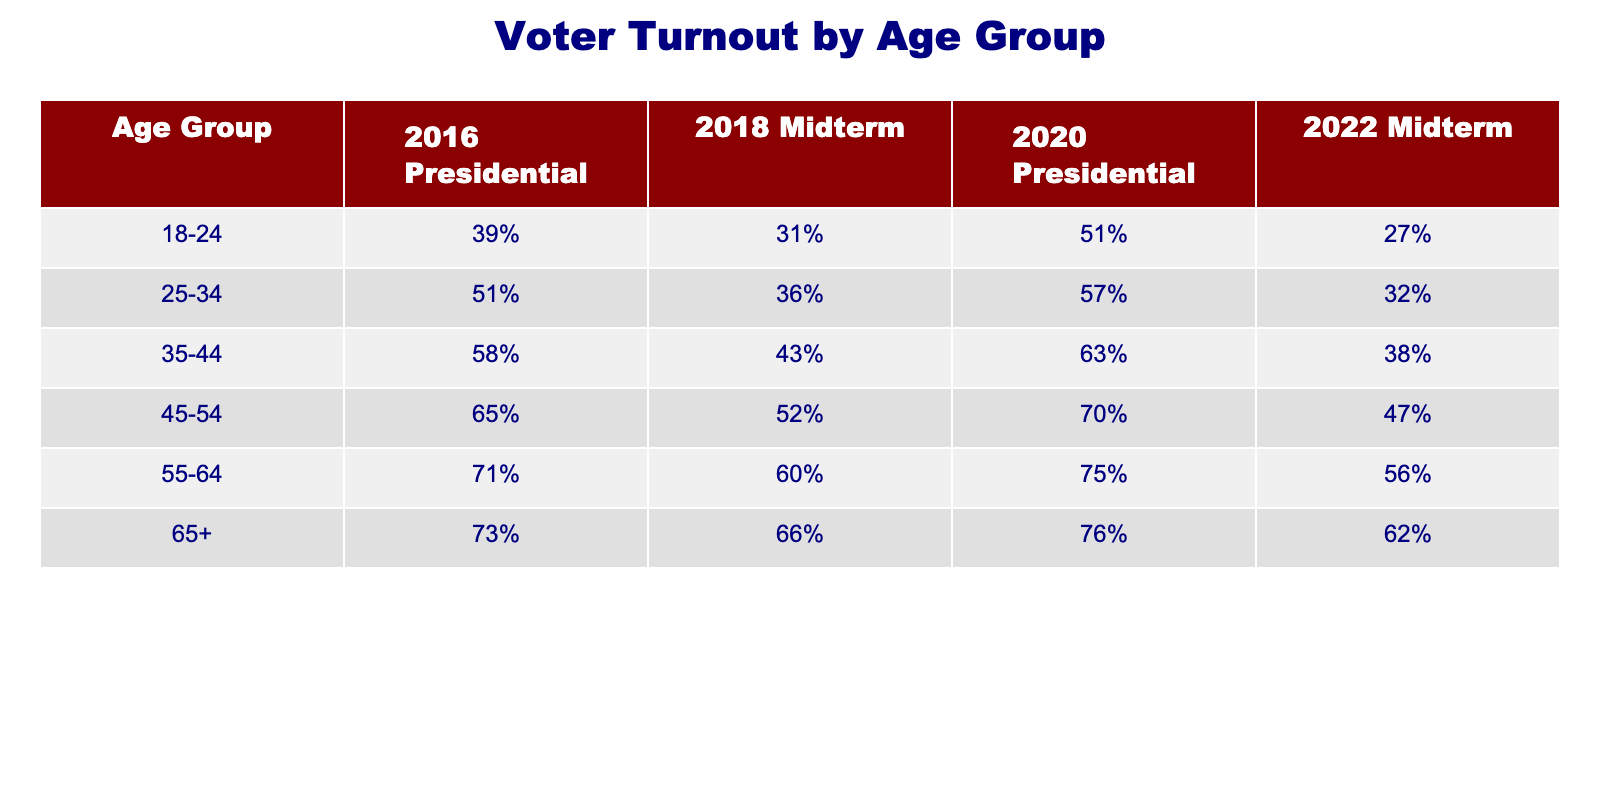What was the voter turnout for the 45-54 age group in the 2022 Midterm? In the table, we look for the row corresponding to the age group 45-54 and read the column for the 2022 Midterm, which shows 47%.
Answer: 47% Which age group had the highest voter turnout in the 2020 Presidential election? We compare the numbers in the 2020 Presidential column across all age groups. The 65+ age group has the highest turnout at 76%.
Answer: 65+ What is the difference in voter turnout between the 18-24 age group in the 2016 Presidential and the 2020 Presidential elections? For the 18-24 age group, the turnout was 39% in 2016 and 51% in 2020. We subtract 39% from 51%, resulting in a difference of 12%.
Answer: 12% Did voter turnout increase for the 35-44 age group from the 2018 Midterm to the 2020 Presidential elections? The voter turnout for the 35-44 age group in the 2018 Midterm was 43%, and in the 2020 Presidential, it was 63%. Since 63% is greater than 43%, the turnout did increase.
Answer: Yes What is the average voter turnout for the 55-64 age group across all the elections? To find the average, we take the turnout values for the 55-64 age group: 71%, 60%, 75%, and 56%. We sum these values (71 + 60 + 75 + 56 = 262) and then divide by the number of elections (4) to get 262/4 = 65.5%.
Answer: 65.5% Which election saw the lowest voter turnout for the 25-34 age group? We look at the turnout values for the 25-34 age group: 51% in 2016, 36% in 2018, 57% in 2020, and 32% in 2022. The lowest turnout is 32% in the 2022 Midterm.
Answer: 2022 Midterm What was the increase in voter turnout for the 65+ age group from the 2018 Midterm to the 2020 Presidential election? The 65+ age group's turnout in the 2018 Midterm was 66% and in the 2020 Presidential it was 76%. We find the difference by subtracting 66% from 76%, which gives us an increase of 10%.
Answer: 10% Is it true that the 55-64 age group had a higher voter turnout in the 2020 Presidential election than the 45-54 age group in the same election? The 55-64 age group's voter turnout in the 2020 Presidential was 75%, while the 45-54 age group had 70%. Since 75% is greater than 70%, the statement is true.
Answer: Yes What was the percentage decrease in voter turnout from the 2016 Presidential to the 2022 Midterm for the 18-24 age group? The 18-24 age group's turnout in 2016 was 39% and in 2022 it was 27%. We find the decrease by subtracting 27% from 39%, which is 12%. To find the percentage decrease, we divide the decrease by the original value: (12% / 39%) * 100 ≈ 30.77%.
Answer: ≈ 30.77% 